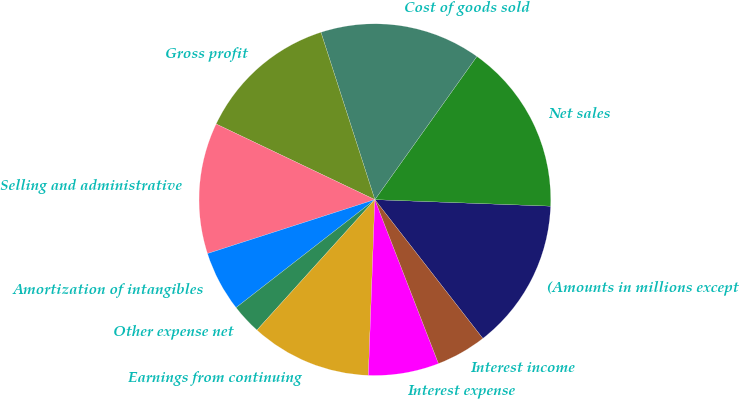Convert chart to OTSL. <chart><loc_0><loc_0><loc_500><loc_500><pie_chart><fcel>(Amounts in millions except<fcel>Net sales<fcel>Cost of goods sold<fcel>Gross profit<fcel>Selling and administrative<fcel>Amortization of intangibles<fcel>Other expense net<fcel>Earnings from continuing<fcel>Interest expense<fcel>Interest income<nl><fcel>13.89%<fcel>15.74%<fcel>14.81%<fcel>12.96%<fcel>12.04%<fcel>5.56%<fcel>2.78%<fcel>11.11%<fcel>6.48%<fcel>4.63%<nl></chart> 